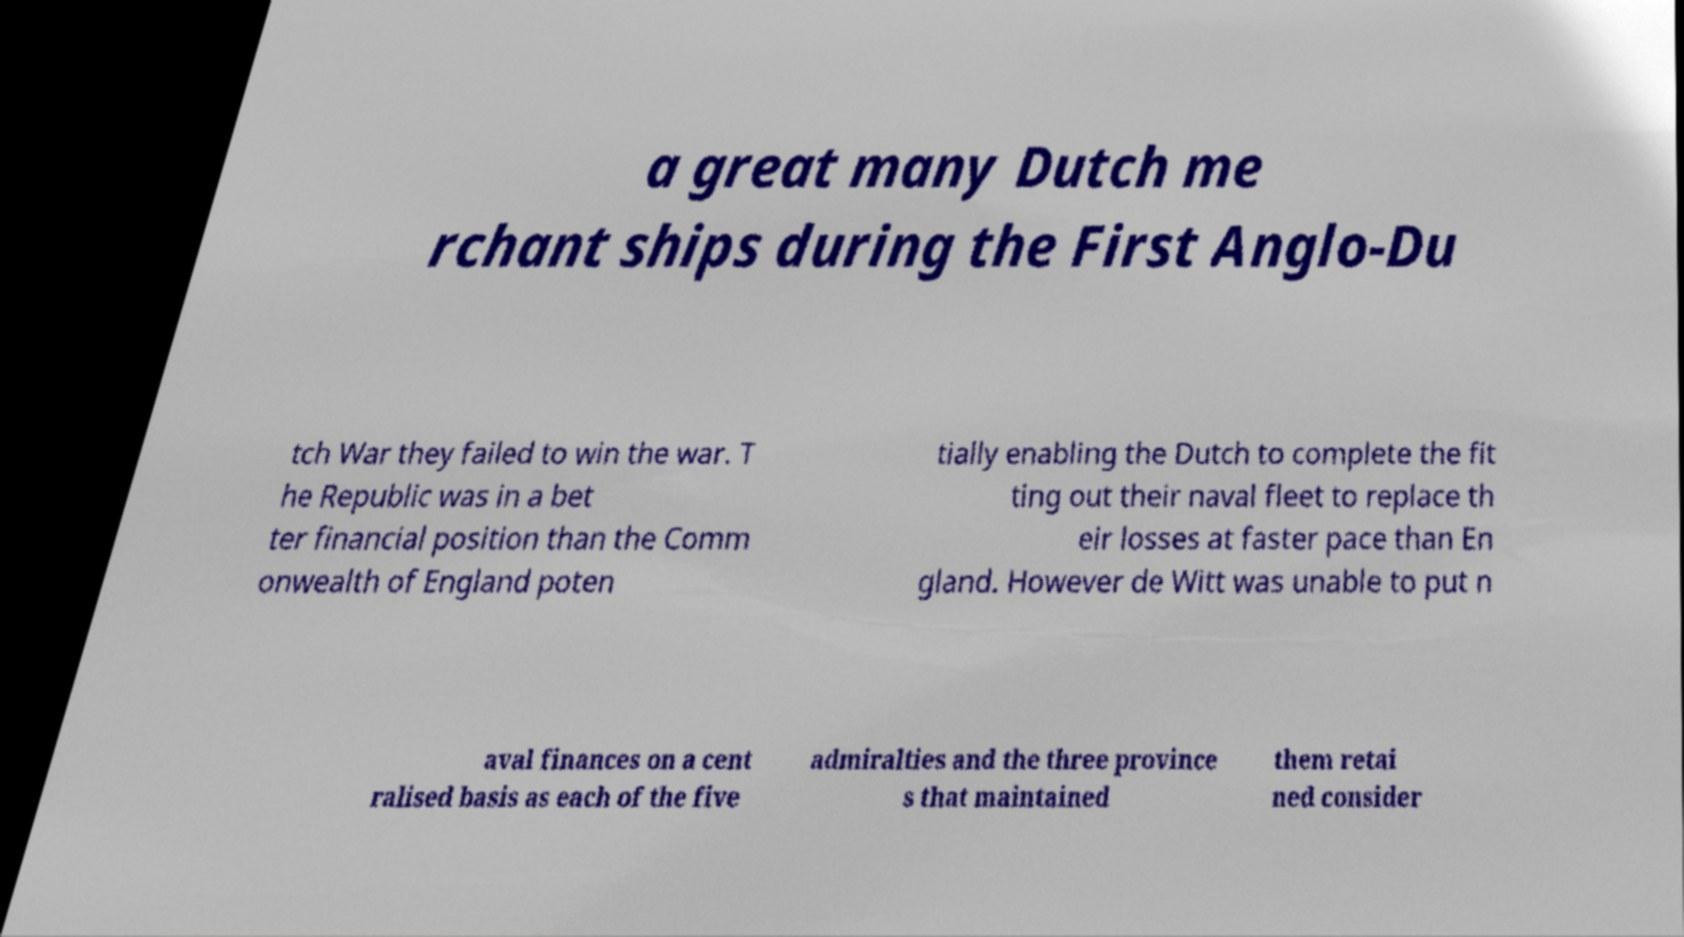Can you accurately transcribe the text from the provided image for me? a great many Dutch me rchant ships during the First Anglo-Du tch War they failed to win the war. T he Republic was in a bet ter financial position than the Comm onwealth of England poten tially enabling the Dutch to complete the fit ting out their naval fleet to replace th eir losses at faster pace than En gland. However de Witt was unable to put n aval finances on a cent ralised basis as each of the five admiralties and the three province s that maintained them retai ned consider 